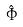<formula> <loc_0><loc_0><loc_500><loc_500>\hat { \Phi }</formula> 